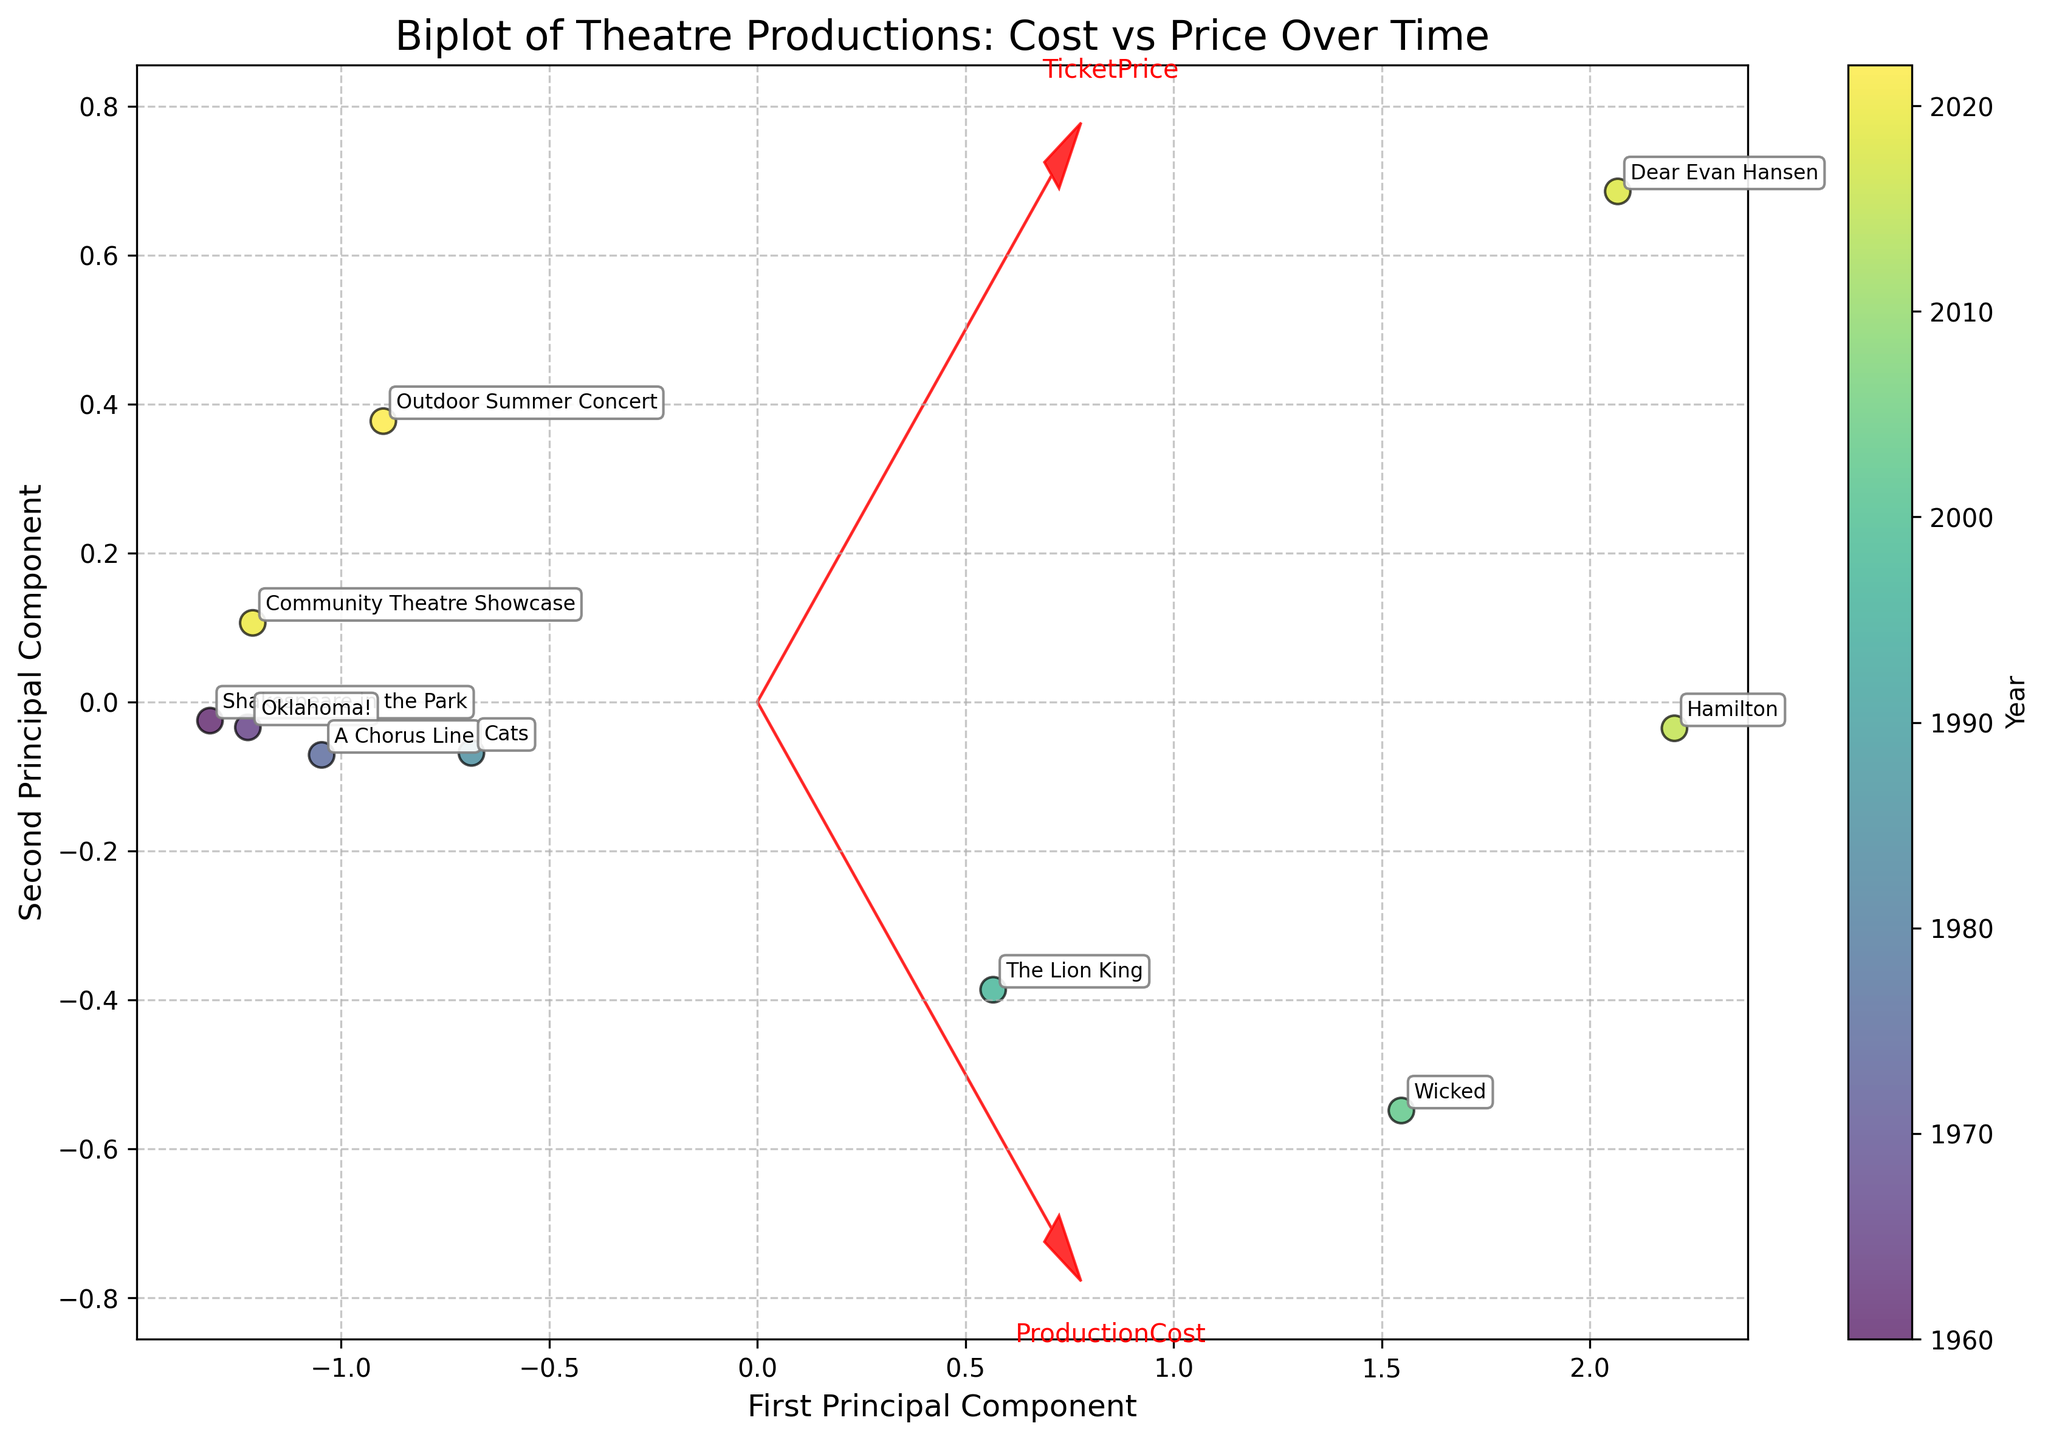What's the title of the figure? The title is presented at the top of the figure and describes the main topic being depicted.
Answer: Biplot of Theatre Productions: Cost vs Price Over Time How many data points are plotted in the figure? Each data point represents a performance, and they are annotated with performance names. By counting these annotations, we find there are 10 data points.
Answer: 10 Which performance had the highest ticket price in the years shown? By inspecting the points marked with performance names, we look for the one labelled with the highest ticket price. 'Dear Evan Hansen' is paired with a value of 175, the highest ticket price displayed.
Answer: Dear Evan Hansen What aspect does the color of the points represent in the plot? By referencing the color bar adjacent to the plot, which labels 'Year', we can determine that the color of points corresponds to the year of each performance.
Answer: Year What two features are indicated by the red arrows in the biplot? The red arrows are usually feature vectors in a biplot and are labelled with the feature they represent. The figure should show 'ProductionCost' and 'TicketPrice'.
Answer: ProductionCost and TicketPrice What trend can be observed between Production Cost and Ticket Price over the years? Moving across the axes of the plot and using the trend indicated by the color gradient and positioning, there's a visible increase in ticket prices and production costs over the years. Performances from more recent years generally have higher costs and prices.
Answer: Increasing trend How does the production cost of 'Hamilton' compare to 'A Chorus Line'? Examine the relative positions of 'Hamilton' and 'A Chorus Line' in terms of their alignment with the ProductionCost arrow. 'Hamilton' is farther from the origin in the direction of the ProductionCost arrow than 'A Chorus Line', indicating a higher production cost.
Answer: Hamilton has a higher production cost What is indicated by how close 'Community Theatre Showcase' is to the origin compared to 'The Lion King'? This can be interpreted as relative cost and price. Since the origin denotes standard mean values, closer points are likely to have production costs and ticket prices closer to the average or lower.
Answer: Community Theatre Showcase has lower production cost and ticket price than The Lion King Which performance is positioned closest to the First Principal Component axis? By noting the placement of the data points concerning the labeled axis, 'Wicked' appears closest to the First Principal Component axis.
Answer: Wicked Do older performances generally cluster closer to the origin or farther away compared to recent performances? By observing the color gradient where older performances (darker colors) are mostly located and comparing their distance from the origin with newer performances (lighter colors), it's clear that older performances are mainly clustered closer to the origin.
Answer: Closer to the origin 